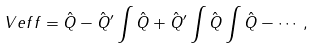<formula> <loc_0><loc_0><loc_500><loc_500>\ V e f f = \hat { Q } - \hat { Q } ^ { \prime } \int \hat { Q } + \hat { Q } ^ { \prime } \int \hat { Q } \int \hat { Q } - \cdots ,</formula> 